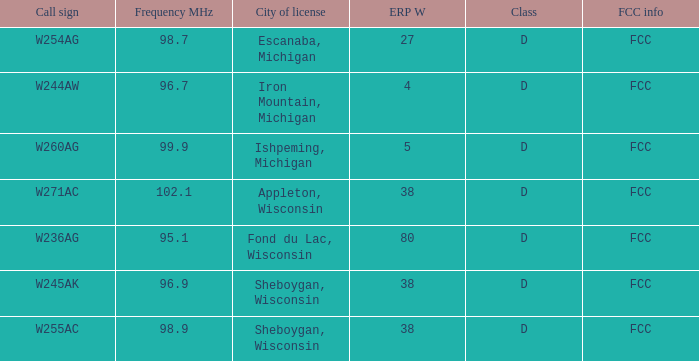What was the ERP W for 96.7 MHz? 4.0. 